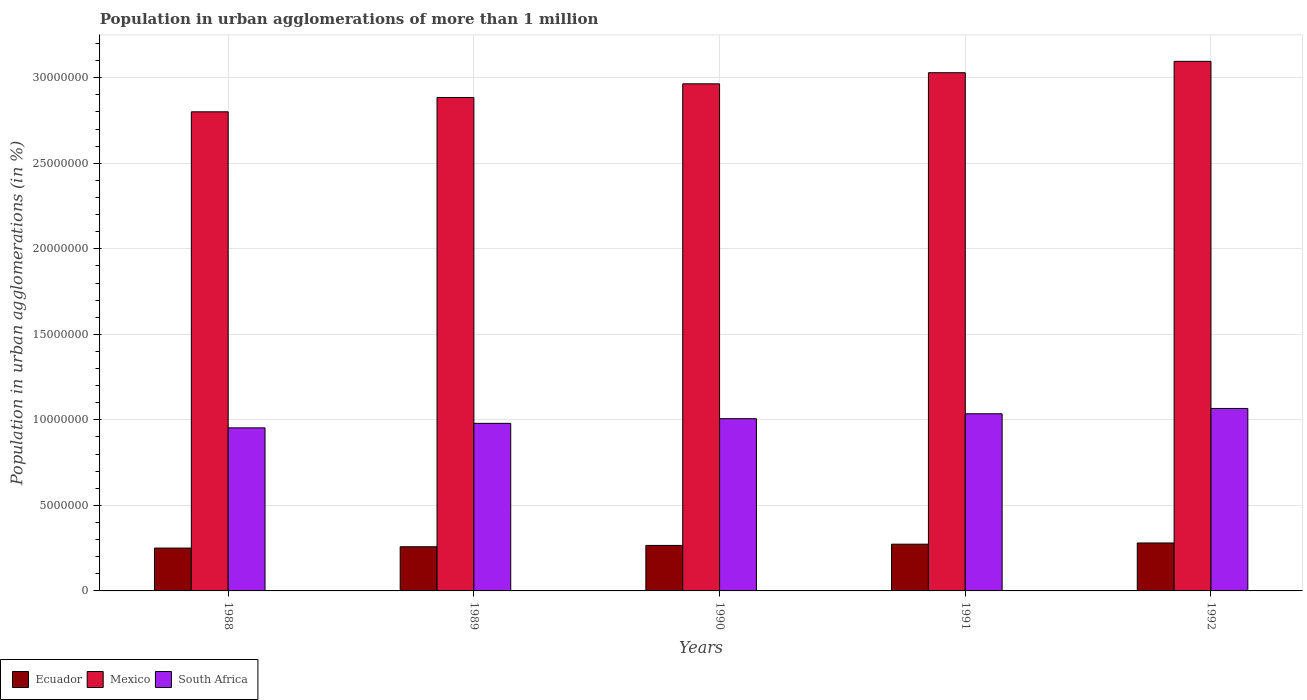How many groups of bars are there?
Provide a short and direct response. 5. Are the number of bars per tick equal to the number of legend labels?
Your answer should be very brief. Yes. Are the number of bars on each tick of the X-axis equal?
Your response must be concise. Yes. What is the label of the 1st group of bars from the left?
Provide a succinct answer. 1988. What is the population in urban agglomerations in South Africa in 1990?
Your response must be concise. 1.01e+07. Across all years, what is the maximum population in urban agglomerations in South Africa?
Keep it short and to the point. 1.07e+07. Across all years, what is the minimum population in urban agglomerations in South Africa?
Give a very brief answer. 9.53e+06. In which year was the population in urban agglomerations in South Africa maximum?
Your response must be concise. 1992. What is the total population in urban agglomerations in Ecuador in the graph?
Your answer should be compact. 1.33e+07. What is the difference between the population in urban agglomerations in Ecuador in 1989 and that in 1990?
Your answer should be compact. -7.87e+04. What is the difference between the population in urban agglomerations in Mexico in 1992 and the population in urban agglomerations in South Africa in 1990?
Your response must be concise. 2.09e+07. What is the average population in urban agglomerations in Ecuador per year?
Offer a very short reply. 2.66e+06. In the year 1989, what is the difference between the population in urban agglomerations in Ecuador and population in urban agglomerations in South Africa?
Keep it short and to the point. -7.22e+06. In how many years, is the population in urban agglomerations in Mexico greater than 3000000 %?
Offer a terse response. 5. What is the ratio of the population in urban agglomerations in South Africa in 1988 to that in 1992?
Provide a short and direct response. 0.89. What is the difference between the highest and the second highest population in urban agglomerations in Ecuador?
Your answer should be compact. 7.03e+04. What is the difference between the highest and the lowest population in urban agglomerations in Mexico?
Offer a terse response. 2.95e+06. Is the sum of the population in urban agglomerations in South Africa in 1989 and 1992 greater than the maximum population in urban agglomerations in Ecuador across all years?
Provide a short and direct response. Yes. What does the 1st bar from the left in 1990 represents?
Provide a short and direct response. Ecuador. What does the 3rd bar from the right in 1989 represents?
Ensure brevity in your answer.  Ecuador. How many bars are there?
Give a very brief answer. 15. Are all the bars in the graph horizontal?
Offer a terse response. No. How are the legend labels stacked?
Make the answer very short. Horizontal. What is the title of the graph?
Make the answer very short. Population in urban agglomerations of more than 1 million. Does "Greenland" appear as one of the legend labels in the graph?
Offer a very short reply. No. What is the label or title of the X-axis?
Your answer should be compact. Years. What is the label or title of the Y-axis?
Keep it short and to the point. Population in urban agglomerations (in %). What is the Population in urban agglomerations (in %) of Ecuador in 1988?
Provide a succinct answer. 2.50e+06. What is the Population in urban agglomerations (in %) of Mexico in 1988?
Keep it short and to the point. 2.80e+07. What is the Population in urban agglomerations (in %) of South Africa in 1988?
Ensure brevity in your answer.  9.53e+06. What is the Population in urban agglomerations (in %) in Ecuador in 1989?
Your answer should be compact. 2.58e+06. What is the Population in urban agglomerations (in %) in Mexico in 1989?
Your answer should be very brief. 2.88e+07. What is the Population in urban agglomerations (in %) in South Africa in 1989?
Provide a succinct answer. 9.80e+06. What is the Population in urban agglomerations (in %) in Ecuador in 1990?
Offer a terse response. 2.66e+06. What is the Population in urban agglomerations (in %) of Mexico in 1990?
Offer a very short reply. 2.96e+07. What is the Population in urban agglomerations (in %) of South Africa in 1990?
Offer a terse response. 1.01e+07. What is the Population in urban agglomerations (in %) of Ecuador in 1991?
Give a very brief answer. 2.73e+06. What is the Population in urban agglomerations (in %) in Mexico in 1991?
Offer a very short reply. 3.03e+07. What is the Population in urban agglomerations (in %) in South Africa in 1991?
Your response must be concise. 1.04e+07. What is the Population in urban agglomerations (in %) of Ecuador in 1992?
Your answer should be very brief. 2.80e+06. What is the Population in urban agglomerations (in %) in Mexico in 1992?
Ensure brevity in your answer.  3.10e+07. What is the Population in urban agglomerations (in %) of South Africa in 1992?
Give a very brief answer. 1.07e+07. Across all years, what is the maximum Population in urban agglomerations (in %) of Ecuador?
Your answer should be very brief. 2.80e+06. Across all years, what is the maximum Population in urban agglomerations (in %) in Mexico?
Offer a terse response. 3.10e+07. Across all years, what is the maximum Population in urban agglomerations (in %) of South Africa?
Give a very brief answer. 1.07e+07. Across all years, what is the minimum Population in urban agglomerations (in %) in Ecuador?
Ensure brevity in your answer.  2.50e+06. Across all years, what is the minimum Population in urban agglomerations (in %) in Mexico?
Provide a short and direct response. 2.80e+07. Across all years, what is the minimum Population in urban agglomerations (in %) in South Africa?
Offer a terse response. 9.53e+06. What is the total Population in urban agglomerations (in %) of Ecuador in the graph?
Provide a short and direct response. 1.33e+07. What is the total Population in urban agglomerations (in %) of Mexico in the graph?
Offer a terse response. 1.48e+08. What is the total Population in urban agglomerations (in %) of South Africa in the graph?
Make the answer very short. 5.04e+07. What is the difference between the Population in urban agglomerations (in %) in Ecuador in 1988 and that in 1989?
Your answer should be compact. -7.63e+04. What is the difference between the Population in urban agglomerations (in %) of Mexico in 1988 and that in 1989?
Keep it short and to the point. -8.37e+05. What is the difference between the Population in urban agglomerations (in %) in South Africa in 1988 and that in 1989?
Your answer should be very brief. -2.63e+05. What is the difference between the Population in urban agglomerations (in %) of Ecuador in 1988 and that in 1990?
Your response must be concise. -1.55e+05. What is the difference between the Population in urban agglomerations (in %) in Mexico in 1988 and that in 1990?
Ensure brevity in your answer.  -1.64e+06. What is the difference between the Population in urban agglomerations (in %) in South Africa in 1988 and that in 1990?
Provide a succinct answer. -5.36e+05. What is the difference between the Population in urban agglomerations (in %) of Ecuador in 1988 and that in 1991?
Make the answer very short. -2.29e+05. What is the difference between the Population in urban agglomerations (in %) of Mexico in 1988 and that in 1991?
Make the answer very short. -2.28e+06. What is the difference between the Population in urban agglomerations (in %) of South Africa in 1988 and that in 1991?
Offer a terse response. -8.23e+05. What is the difference between the Population in urban agglomerations (in %) of Ecuador in 1988 and that in 1992?
Offer a terse response. -2.99e+05. What is the difference between the Population in urban agglomerations (in %) of Mexico in 1988 and that in 1992?
Provide a succinct answer. -2.95e+06. What is the difference between the Population in urban agglomerations (in %) in South Africa in 1988 and that in 1992?
Ensure brevity in your answer.  -1.13e+06. What is the difference between the Population in urban agglomerations (in %) of Ecuador in 1989 and that in 1990?
Keep it short and to the point. -7.87e+04. What is the difference between the Population in urban agglomerations (in %) of Mexico in 1989 and that in 1990?
Provide a short and direct response. -7.99e+05. What is the difference between the Population in urban agglomerations (in %) in South Africa in 1989 and that in 1990?
Ensure brevity in your answer.  -2.73e+05. What is the difference between the Population in urban agglomerations (in %) in Ecuador in 1989 and that in 1991?
Your response must be concise. -1.52e+05. What is the difference between the Population in urban agglomerations (in %) in Mexico in 1989 and that in 1991?
Offer a very short reply. -1.45e+06. What is the difference between the Population in urban agglomerations (in %) of South Africa in 1989 and that in 1991?
Your response must be concise. -5.60e+05. What is the difference between the Population in urban agglomerations (in %) of Ecuador in 1989 and that in 1992?
Offer a terse response. -2.23e+05. What is the difference between the Population in urban agglomerations (in %) in Mexico in 1989 and that in 1992?
Provide a short and direct response. -2.11e+06. What is the difference between the Population in urban agglomerations (in %) of South Africa in 1989 and that in 1992?
Provide a succinct answer. -8.70e+05. What is the difference between the Population in urban agglomerations (in %) in Ecuador in 1990 and that in 1991?
Your answer should be compact. -7.35e+04. What is the difference between the Population in urban agglomerations (in %) of Mexico in 1990 and that in 1991?
Provide a succinct answer. -6.48e+05. What is the difference between the Population in urban agglomerations (in %) in South Africa in 1990 and that in 1991?
Make the answer very short. -2.87e+05. What is the difference between the Population in urban agglomerations (in %) in Ecuador in 1990 and that in 1992?
Make the answer very short. -1.44e+05. What is the difference between the Population in urban agglomerations (in %) of Mexico in 1990 and that in 1992?
Ensure brevity in your answer.  -1.31e+06. What is the difference between the Population in urban agglomerations (in %) in South Africa in 1990 and that in 1992?
Provide a succinct answer. -5.97e+05. What is the difference between the Population in urban agglomerations (in %) of Ecuador in 1991 and that in 1992?
Your response must be concise. -7.03e+04. What is the difference between the Population in urban agglomerations (in %) in Mexico in 1991 and that in 1992?
Your answer should be very brief. -6.65e+05. What is the difference between the Population in urban agglomerations (in %) in South Africa in 1991 and that in 1992?
Keep it short and to the point. -3.10e+05. What is the difference between the Population in urban agglomerations (in %) of Ecuador in 1988 and the Population in urban agglomerations (in %) of Mexico in 1989?
Ensure brevity in your answer.  -2.63e+07. What is the difference between the Population in urban agglomerations (in %) in Ecuador in 1988 and the Population in urban agglomerations (in %) in South Africa in 1989?
Provide a succinct answer. -7.29e+06. What is the difference between the Population in urban agglomerations (in %) of Mexico in 1988 and the Population in urban agglomerations (in %) of South Africa in 1989?
Your answer should be compact. 1.82e+07. What is the difference between the Population in urban agglomerations (in %) of Ecuador in 1988 and the Population in urban agglomerations (in %) of Mexico in 1990?
Provide a succinct answer. -2.71e+07. What is the difference between the Population in urban agglomerations (in %) in Ecuador in 1988 and the Population in urban agglomerations (in %) in South Africa in 1990?
Offer a terse response. -7.56e+06. What is the difference between the Population in urban agglomerations (in %) of Mexico in 1988 and the Population in urban agglomerations (in %) of South Africa in 1990?
Your answer should be compact. 1.79e+07. What is the difference between the Population in urban agglomerations (in %) of Ecuador in 1988 and the Population in urban agglomerations (in %) of Mexico in 1991?
Provide a short and direct response. -2.78e+07. What is the difference between the Population in urban agglomerations (in %) in Ecuador in 1988 and the Population in urban agglomerations (in %) in South Africa in 1991?
Offer a terse response. -7.85e+06. What is the difference between the Population in urban agglomerations (in %) in Mexico in 1988 and the Population in urban agglomerations (in %) in South Africa in 1991?
Provide a succinct answer. 1.77e+07. What is the difference between the Population in urban agglomerations (in %) of Ecuador in 1988 and the Population in urban agglomerations (in %) of Mexico in 1992?
Your response must be concise. -2.85e+07. What is the difference between the Population in urban agglomerations (in %) of Ecuador in 1988 and the Population in urban agglomerations (in %) of South Africa in 1992?
Make the answer very short. -8.16e+06. What is the difference between the Population in urban agglomerations (in %) of Mexico in 1988 and the Population in urban agglomerations (in %) of South Africa in 1992?
Offer a terse response. 1.73e+07. What is the difference between the Population in urban agglomerations (in %) of Ecuador in 1989 and the Population in urban agglomerations (in %) of Mexico in 1990?
Offer a terse response. -2.71e+07. What is the difference between the Population in urban agglomerations (in %) in Ecuador in 1989 and the Population in urban agglomerations (in %) in South Africa in 1990?
Your answer should be very brief. -7.49e+06. What is the difference between the Population in urban agglomerations (in %) of Mexico in 1989 and the Population in urban agglomerations (in %) of South Africa in 1990?
Make the answer very short. 1.88e+07. What is the difference between the Population in urban agglomerations (in %) in Ecuador in 1989 and the Population in urban agglomerations (in %) in Mexico in 1991?
Your answer should be compact. -2.77e+07. What is the difference between the Population in urban agglomerations (in %) in Ecuador in 1989 and the Population in urban agglomerations (in %) in South Africa in 1991?
Offer a very short reply. -7.78e+06. What is the difference between the Population in urban agglomerations (in %) in Mexico in 1989 and the Population in urban agglomerations (in %) in South Africa in 1991?
Provide a short and direct response. 1.85e+07. What is the difference between the Population in urban agglomerations (in %) of Ecuador in 1989 and the Population in urban agglomerations (in %) of Mexico in 1992?
Your answer should be very brief. -2.84e+07. What is the difference between the Population in urban agglomerations (in %) in Ecuador in 1989 and the Population in urban agglomerations (in %) in South Africa in 1992?
Offer a terse response. -8.09e+06. What is the difference between the Population in urban agglomerations (in %) of Mexico in 1989 and the Population in urban agglomerations (in %) of South Africa in 1992?
Give a very brief answer. 1.82e+07. What is the difference between the Population in urban agglomerations (in %) of Ecuador in 1990 and the Population in urban agglomerations (in %) of Mexico in 1991?
Ensure brevity in your answer.  -2.76e+07. What is the difference between the Population in urban agglomerations (in %) in Ecuador in 1990 and the Population in urban agglomerations (in %) in South Africa in 1991?
Your answer should be very brief. -7.70e+06. What is the difference between the Population in urban agglomerations (in %) in Mexico in 1990 and the Population in urban agglomerations (in %) in South Africa in 1991?
Ensure brevity in your answer.  1.93e+07. What is the difference between the Population in urban agglomerations (in %) in Ecuador in 1990 and the Population in urban agglomerations (in %) in Mexico in 1992?
Make the answer very short. -2.83e+07. What is the difference between the Population in urban agglomerations (in %) in Ecuador in 1990 and the Population in urban agglomerations (in %) in South Africa in 1992?
Offer a terse response. -8.01e+06. What is the difference between the Population in urban agglomerations (in %) in Mexico in 1990 and the Population in urban agglomerations (in %) in South Africa in 1992?
Provide a succinct answer. 1.90e+07. What is the difference between the Population in urban agglomerations (in %) of Ecuador in 1991 and the Population in urban agglomerations (in %) of Mexico in 1992?
Your answer should be very brief. -2.82e+07. What is the difference between the Population in urban agglomerations (in %) in Ecuador in 1991 and the Population in urban agglomerations (in %) in South Africa in 1992?
Ensure brevity in your answer.  -7.93e+06. What is the difference between the Population in urban agglomerations (in %) of Mexico in 1991 and the Population in urban agglomerations (in %) of South Africa in 1992?
Give a very brief answer. 1.96e+07. What is the average Population in urban agglomerations (in %) in Ecuador per year?
Your answer should be compact. 2.66e+06. What is the average Population in urban agglomerations (in %) of Mexico per year?
Keep it short and to the point. 2.95e+07. What is the average Population in urban agglomerations (in %) of South Africa per year?
Provide a short and direct response. 1.01e+07. In the year 1988, what is the difference between the Population in urban agglomerations (in %) in Ecuador and Population in urban agglomerations (in %) in Mexico?
Offer a very short reply. -2.55e+07. In the year 1988, what is the difference between the Population in urban agglomerations (in %) of Ecuador and Population in urban agglomerations (in %) of South Africa?
Keep it short and to the point. -7.03e+06. In the year 1988, what is the difference between the Population in urban agglomerations (in %) in Mexico and Population in urban agglomerations (in %) in South Africa?
Your response must be concise. 1.85e+07. In the year 1989, what is the difference between the Population in urban agglomerations (in %) in Ecuador and Population in urban agglomerations (in %) in Mexico?
Keep it short and to the point. -2.63e+07. In the year 1989, what is the difference between the Population in urban agglomerations (in %) of Ecuador and Population in urban agglomerations (in %) of South Africa?
Give a very brief answer. -7.22e+06. In the year 1989, what is the difference between the Population in urban agglomerations (in %) of Mexico and Population in urban agglomerations (in %) of South Africa?
Your response must be concise. 1.90e+07. In the year 1990, what is the difference between the Population in urban agglomerations (in %) in Ecuador and Population in urban agglomerations (in %) in Mexico?
Keep it short and to the point. -2.70e+07. In the year 1990, what is the difference between the Population in urban agglomerations (in %) in Ecuador and Population in urban agglomerations (in %) in South Africa?
Provide a succinct answer. -7.41e+06. In the year 1990, what is the difference between the Population in urban agglomerations (in %) of Mexico and Population in urban agglomerations (in %) of South Africa?
Make the answer very short. 1.96e+07. In the year 1991, what is the difference between the Population in urban agglomerations (in %) in Ecuador and Population in urban agglomerations (in %) in Mexico?
Keep it short and to the point. -2.76e+07. In the year 1991, what is the difference between the Population in urban agglomerations (in %) of Ecuador and Population in urban agglomerations (in %) of South Africa?
Your answer should be compact. -7.62e+06. In the year 1991, what is the difference between the Population in urban agglomerations (in %) in Mexico and Population in urban agglomerations (in %) in South Africa?
Offer a terse response. 1.99e+07. In the year 1992, what is the difference between the Population in urban agglomerations (in %) of Ecuador and Population in urban agglomerations (in %) of Mexico?
Provide a short and direct response. -2.82e+07. In the year 1992, what is the difference between the Population in urban agglomerations (in %) of Ecuador and Population in urban agglomerations (in %) of South Africa?
Your response must be concise. -7.86e+06. In the year 1992, what is the difference between the Population in urban agglomerations (in %) in Mexico and Population in urban agglomerations (in %) in South Africa?
Offer a terse response. 2.03e+07. What is the ratio of the Population in urban agglomerations (in %) of Ecuador in 1988 to that in 1989?
Provide a succinct answer. 0.97. What is the ratio of the Population in urban agglomerations (in %) in Mexico in 1988 to that in 1989?
Give a very brief answer. 0.97. What is the ratio of the Population in urban agglomerations (in %) in South Africa in 1988 to that in 1989?
Offer a terse response. 0.97. What is the ratio of the Population in urban agglomerations (in %) of Ecuador in 1988 to that in 1990?
Your response must be concise. 0.94. What is the ratio of the Population in urban agglomerations (in %) in Mexico in 1988 to that in 1990?
Give a very brief answer. 0.94. What is the ratio of the Population in urban agglomerations (in %) of South Africa in 1988 to that in 1990?
Provide a short and direct response. 0.95. What is the ratio of the Population in urban agglomerations (in %) in Ecuador in 1988 to that in 1991?
Offer a terse response. 0.92. What is the ratio of the Population in urban agglomerations (in %) in Mexico in 1988 to that in 1991?
Your response must be concise. 0.92. What is the ratio of the Population in urban agglomerations (in %) of South Africa in 1988 to that in 1991?
Offer a terse response. 0.92. What is the ratio of the Population in urban agglomerations (in %) of Ecuador in 1988 to that in 1992?
Your answer should be very brief. 0.89. What is the ratio of the Population in urban agglomerations (in %) in Mexico in 1988 to that in 1992?
Provide a succinct answer. 0.9. What is the ratio of the Population in urban agglomerations (in %) of South Africa in 1988 to that in 1992?
Give a very brief answer. 0.89. What is the ratio of the Population in urban agglomerations (in %) in Ecuador in 1989 to that in 1990?
Your response must be concise. 0.97. What is the ratio of the Population in urban agglomerations (in %) of Mexico in 1989 to that in 1990?
Offer a terse response. 0.97. What is the ratio of the Population in urban agglomerations (in %) in South Africa in 1989 to that in 1990?
Provide a succinct answer. 0.97. What is the ratio of the Population in urban agglomerations (in %) in Ecuador in 1989 to that in 1991?
Give a very brief answer. 0.94. What is the ratio of the Population in urban agglomerations (in %) of Mexico in 1989 to that in 1991?
Provide a short and direct response. 0.95. What is the ratio of the Population in urban agglomerations (in %) in South Africa in 1989 to that in 1991?
Give a very brief answer. 0.95. What is the ratio of the Population in urban agglomerations (in %) of Ecuador in 1989 to that in 1992?
Your response must be concise. 0.92. What is the ratio of the Population in urban agglomerations (in %) of Mexico in 1989 to that in 1992?
Offer a terse response. 0.93. What is the ratio of the Population in urban agglomerations (in %) in South Africa in 1989 to that in 1992?
Provide a succinct answer. 0.92. What is the ratio of the Population in urban agglomerations (in %) of Ecuador in 1990 to that in 1991?
Make the answer very short. 0.97. What is the ratio of the Population in urban agglomerations (in %) of Mexico in 1990 to that in 1991?
Ensure brevity in your answer.  0.98. What is the ratio of the Population in urban agglomerations (in %) of South Africa in 1990 to that in 1991?
Ensure brevity in your answer.  0.97. What is the ratio of the Population in urban agglomerations (in %) in Ecuador in 1990 to that in 1992?
Offer a terse response. 0.95. What is the ratio of the Population in urban agglomerations (in %) of Mexico in 1990 to that in 1992?
Your answer should be very brief. 0.96. What is the ratio of the Population in urban agglomerations (in %) in South Africa in 1990 to that in 1992?
Provide a short and direct response. 0.94. What is the ratio of the Population in urban agglomerations (in %) of Ecuador in 1991 to that in 1992?
Keep it short and to the point. 0.97. What is the ratio of the Population in urban agglomerations (in %) in Mexico in 1991 to that in 1992?
Offer a very short reply. 0.98. What is the ratio of the Population in urban agglomerations (in %) of South Africa in 1991 to that in 1992?
Give a very brief answer. 0.97. What is the difference between the highest and the second highest Population in urban agglomerations (in %) in Ecuador?
Provide a short and direct response. 7.03e+04. What is the difference between the highest and the second highest Population in urban agglomerations (in %) of Mexico?
Provide a short and direct response. 6.65e+05. What is the difference between the highest and the second highest Population in urban agglomerations (in %) of South Africa?
Make the answer very short. 3.10e+05. What is the difference between the highest and the lowest Population in urban agglomerations (in %) in Ecuador?
Provide a short and direct response. 2.99e+05. What is the difference between the highest and the lowest Population in urban agglomerations (in %) in Mexico?
Offer a terse response. 2.95e+06. What is the difference between the highest and the lowest Population in urban agglomerations (in %) in South Africa?
Your response must be concise. 1.13e+06. 